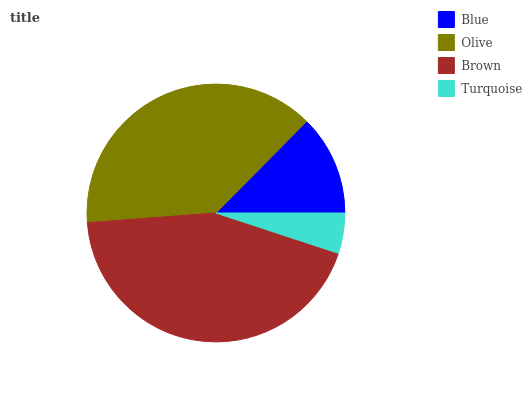Is Turquoise the minimum?
Answer yes or no. Yes. Is Brown the maximum?
Answer yes or no. Yes. Is Olive the minimum?
Answer yes or no. No. Is Olive the maximum?
Answer yes or no. No. Is Olive greater than Blue?
Answer yes or no. Yes. Is Blue less than Olive?
Answer yes or no. Yes. Is Blue greater than Olive?
Answer yes or no. No. Is Olive less than Blue?
Answer yes or no. No. Is Olive the high median?
Answer yes or no. Yes. Is Blue the low median?
Answer yes or no. Yes. Is Blue the high median?
Answer yes or no. No. Is Turquoise the low median?
Answer yes or no. No. 